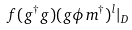Convert formula to latex. <formula><loc_0><loc_0><loc_500><loc_500>f ( g ^ { \dagger } g ) ( g \phi m ^ { \dagger } ) ^ { l } | _ { D }</formula> 